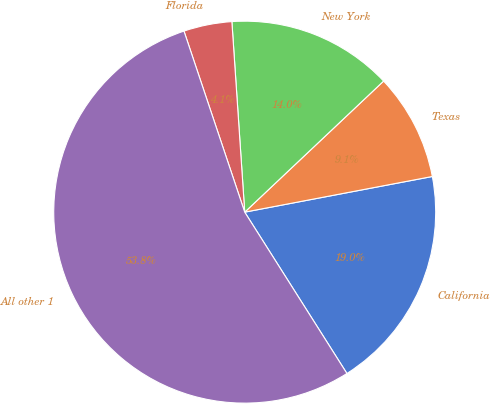<chart> <loc_0><loc_0><loc_500><loc_500><pie_chart><fcel>California<fcel>Texas<fcel>New York<fcel>Florida<fcel>All other 1<nl><fcel>19.0%<fcel>9.05%<fcel>14.03%<fcel>4.08%<fcel>53.83%<nl></chart> 